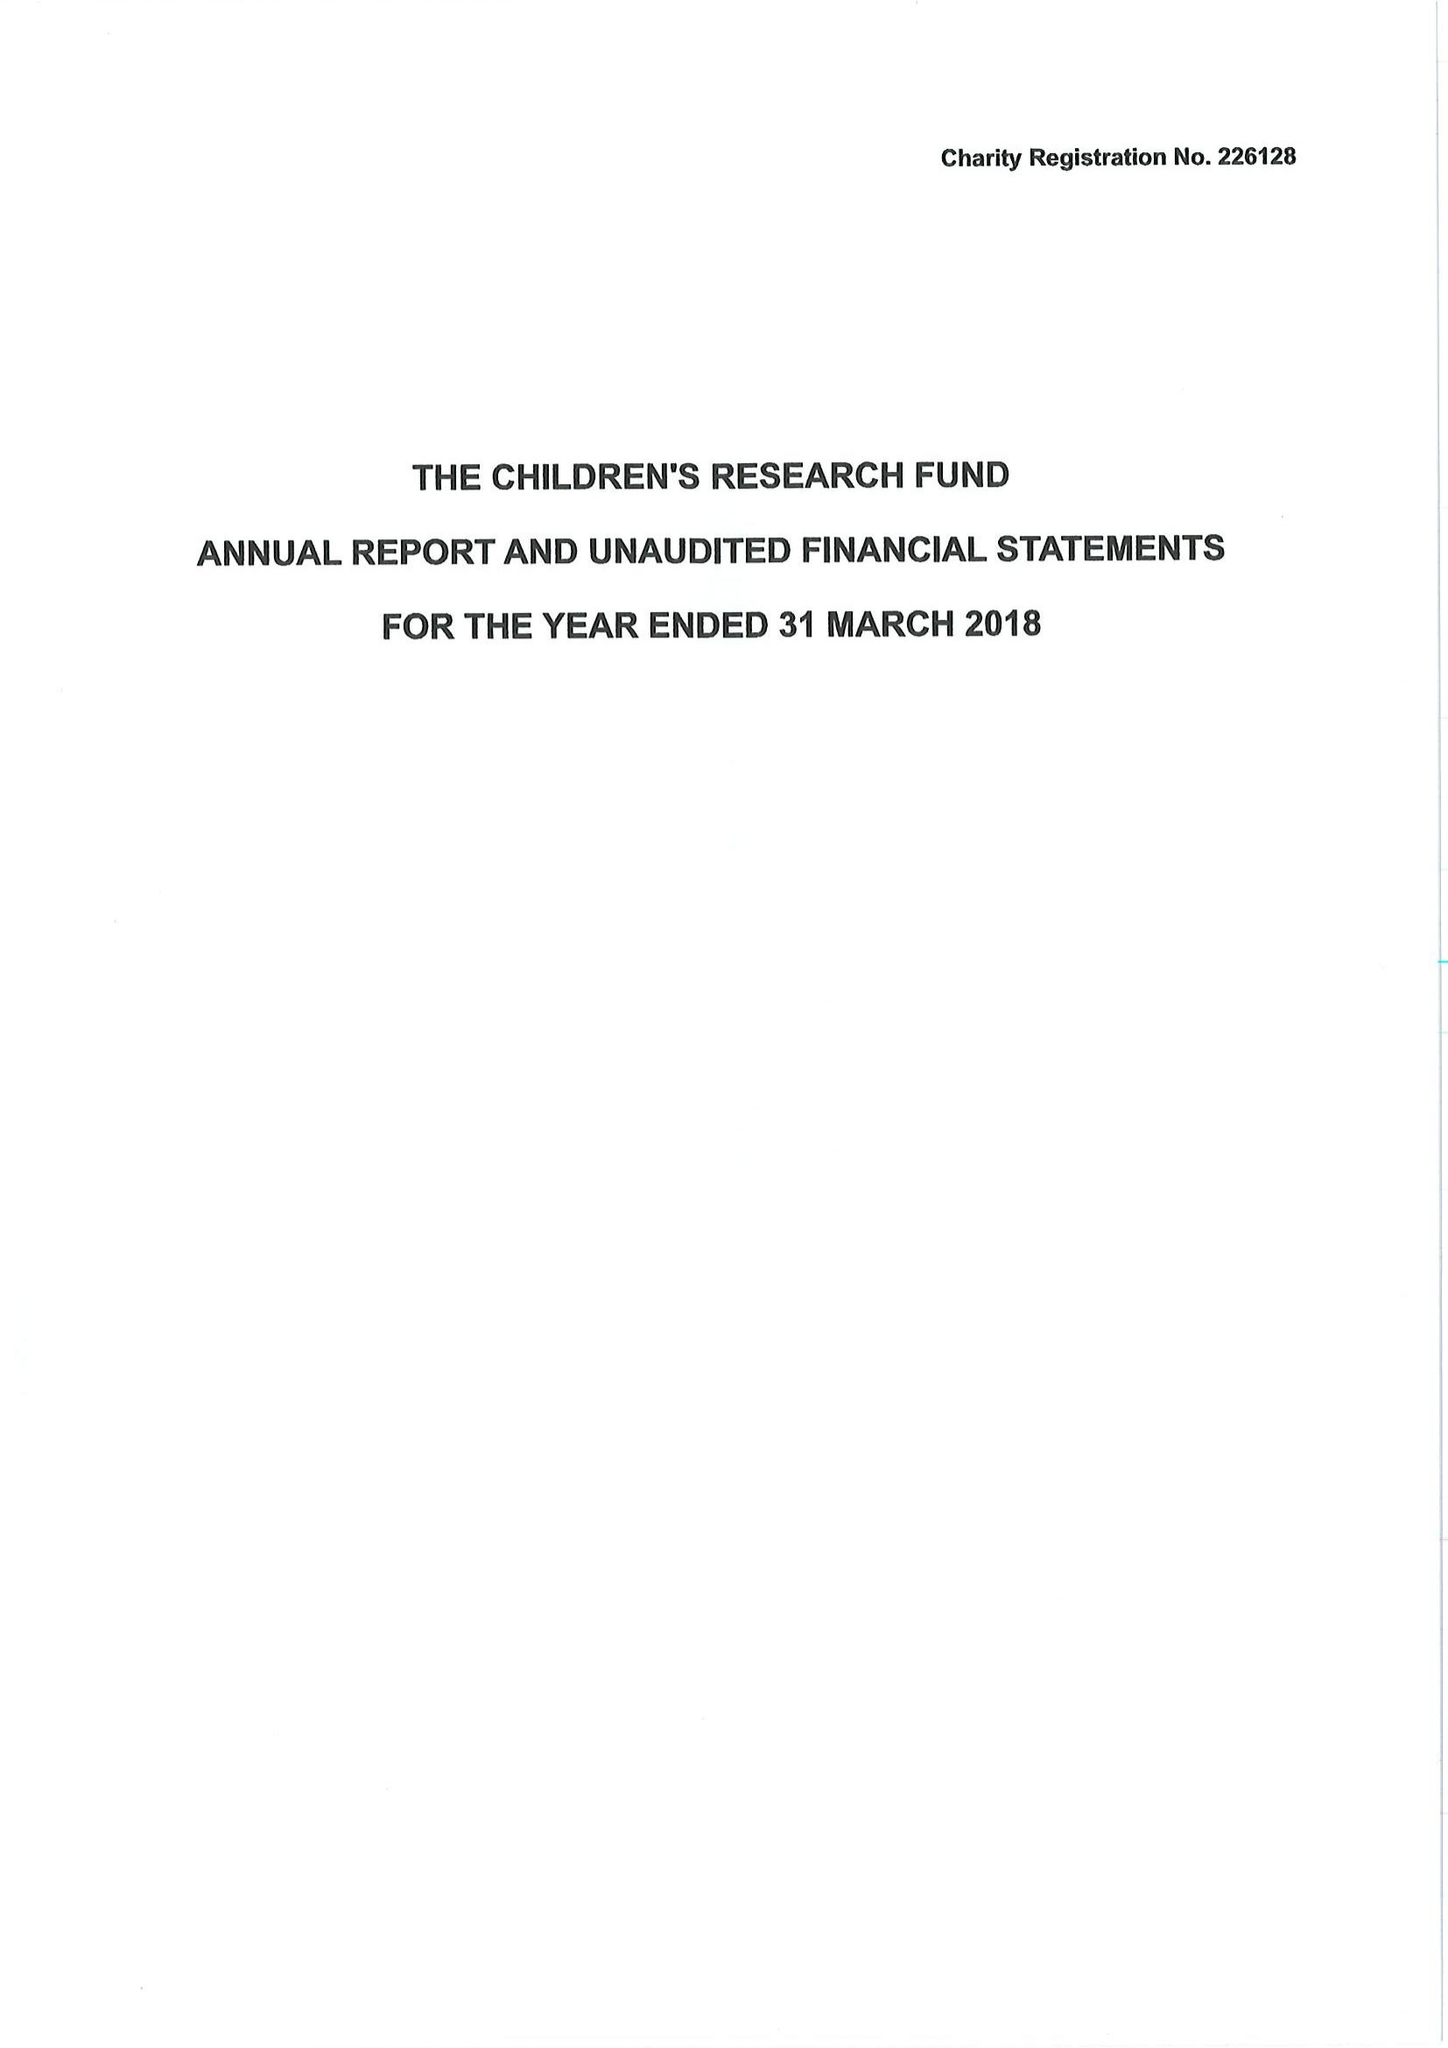What is the value for the report_date?
Answer the question using a single word or phrase. 2018-03-31 